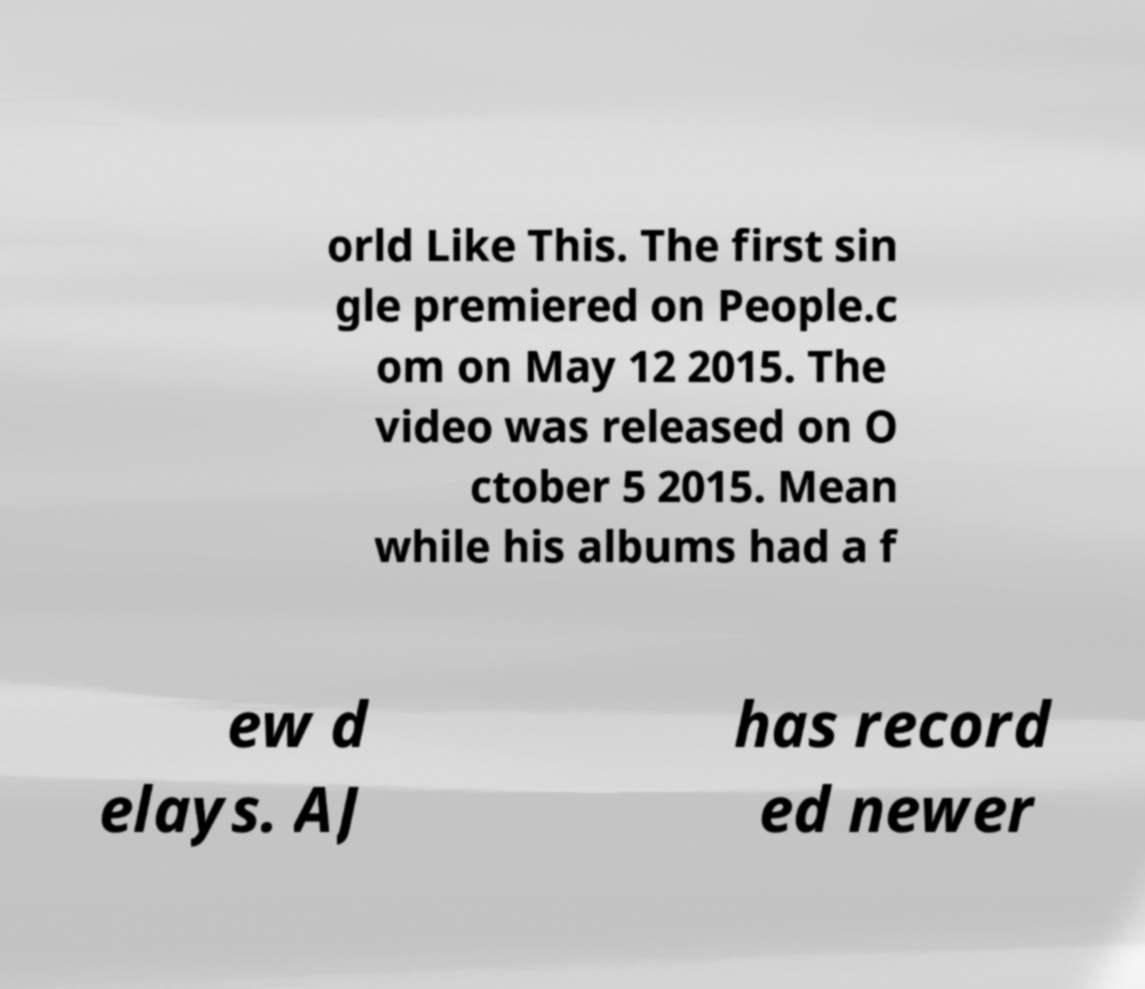Please identify and transcribe the text found in this image. orld Like This. The first sin gle premiered on People.c om on May 12 2015. The video was released on O ctober 5 2015. Mean while his albums had a f ew d elays. AJ has record ed newer 